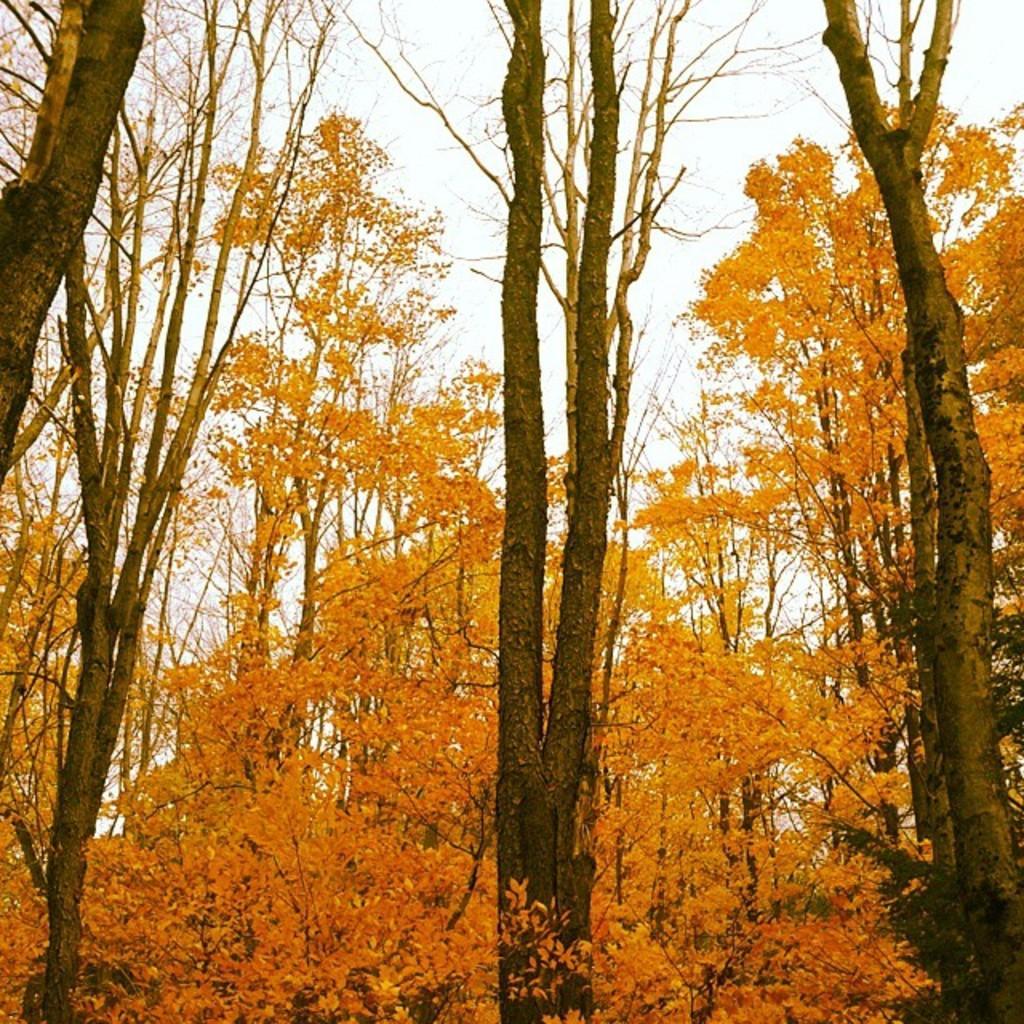Can you describe this image briefly? In this image we can see the trees. In the background we can see the sky. 